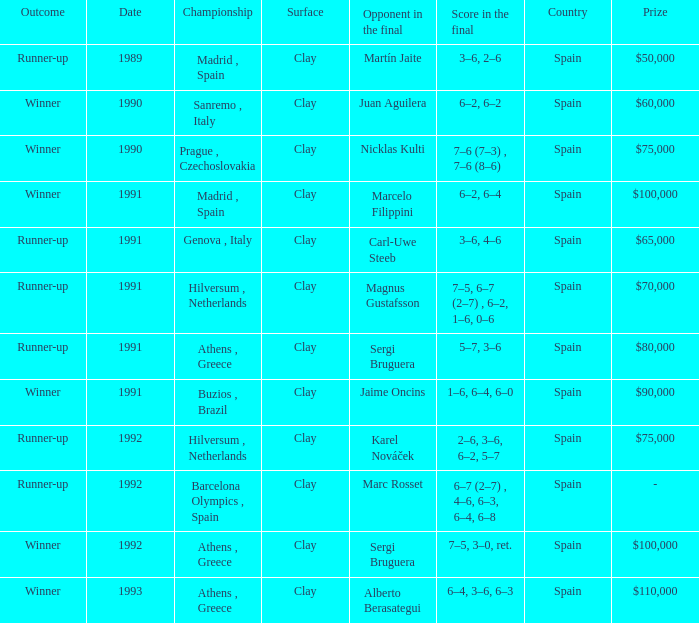What is Score In The Final, when Championship is "Athens , Greece", and when Outcome is "Winner"? 7–5, 3–0, ret., 6–4, 3–6, 6–3. 